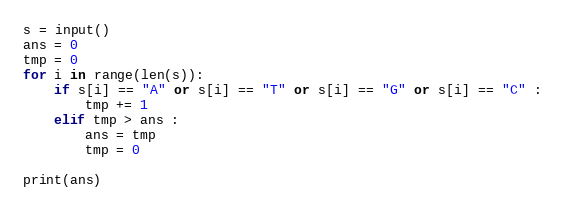Convert code to text. <code><loc_0><loc_0><loc_500><loc_500><_Python_>s = input()
ans = 0
tmp = 0
for i in range(len(s)):
    if s[i] == "A" or s[i] == "T" or s[i] == "G" or s[i] == "C" :
        tmp += 1
    elif tmp > ans :
        ans = tmp
        tmp = 0

print(ans)</code> 